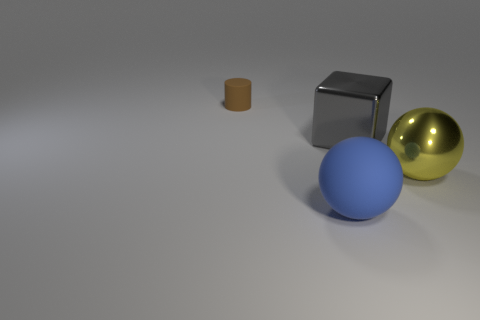Add 1 small yellow objects. How many objects exist? 5 Subtract 0 green blocks. How many objects are left? 4 Subtract all cylinders. How many objects are left? 3 Subtract all yellow balls. Subtract all purple metal things. How many objects are left? 3 Add 3 large metal objects. How many large metal objects are left? 5 Add 4 large yellow metal spheres. How many large yellow metal spheres exist? 5 